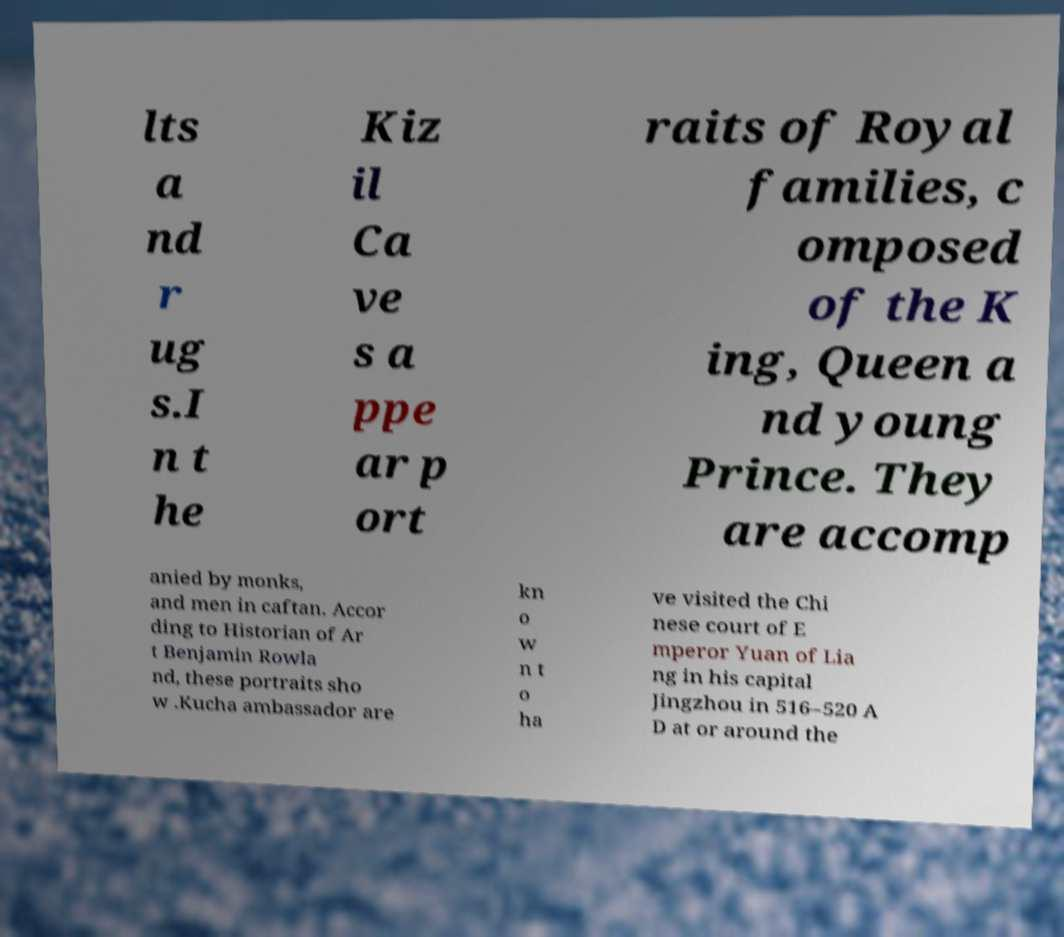Could you extract and type out the text from this image? lts a nd r ug s.I n t he Kiz il Ca ve s a ppe ar p ort raits of Royal families, c omposed of the K ing, Queen a nd young Prince. They are accomp anied by monks, and men in caftan. Accor ding to Historian of Ar t Benjamin Rowla nd, these portraits sho w .Kucha ambassador are kn o w n t o ha ve visited the Chi nese court of E mperor Yuan of Lia ng in his capital Jingzhou in 516–520 A D at or around the 